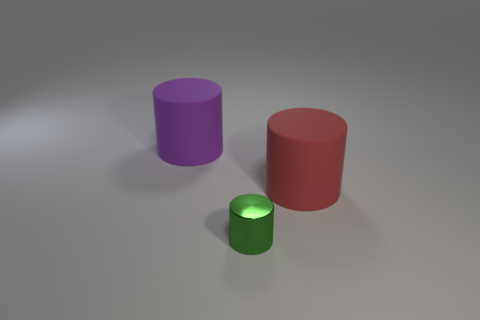Subtract all large red matte cylinders. How many cylinders are left? 2 Subtract all green cylinders. How many cylinders are left? 2 Add 2 big purple matte things. How many objects exist? 5 Subtract 1 cylinders. How many cylinders are left? 2 Subtract all cylinders. Subtract all blue metallic spheres. How many objects are left? 0 Add 3 rubber things. How many rubber things are left? 5 Add 3 big rubber cylinders. How many big rubber cylinders exist? 5 Subtract 0 gray cylinders. How many objects are left? 3 Subtract all red cylinders. Subtract all gray cubes. How many cylinders are left? 2 Subtract all gray spheres. How many green cylinders are left? 1 